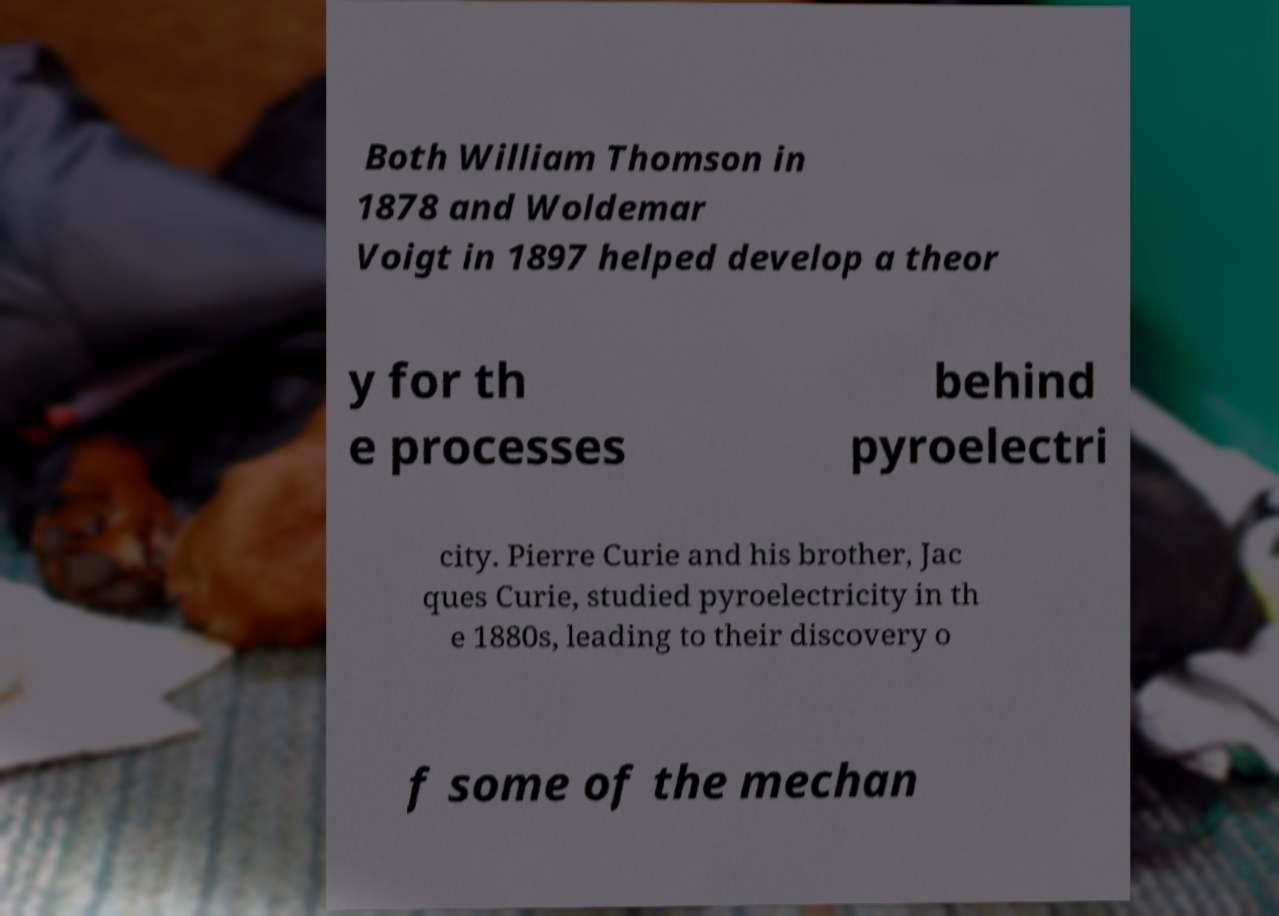For documentation purposes, I need the text within this image transcribed. Could you provide that? Both William Thomson in 1878 and Woldemar Voigt in 1897 helped develop a theor y for th e processes behind pyroelectri city. Pierre Curie and his brother, Jac ques Curie, studied pyroelectricity in th e 1880s, leading to their discovery o f some of the mechan 